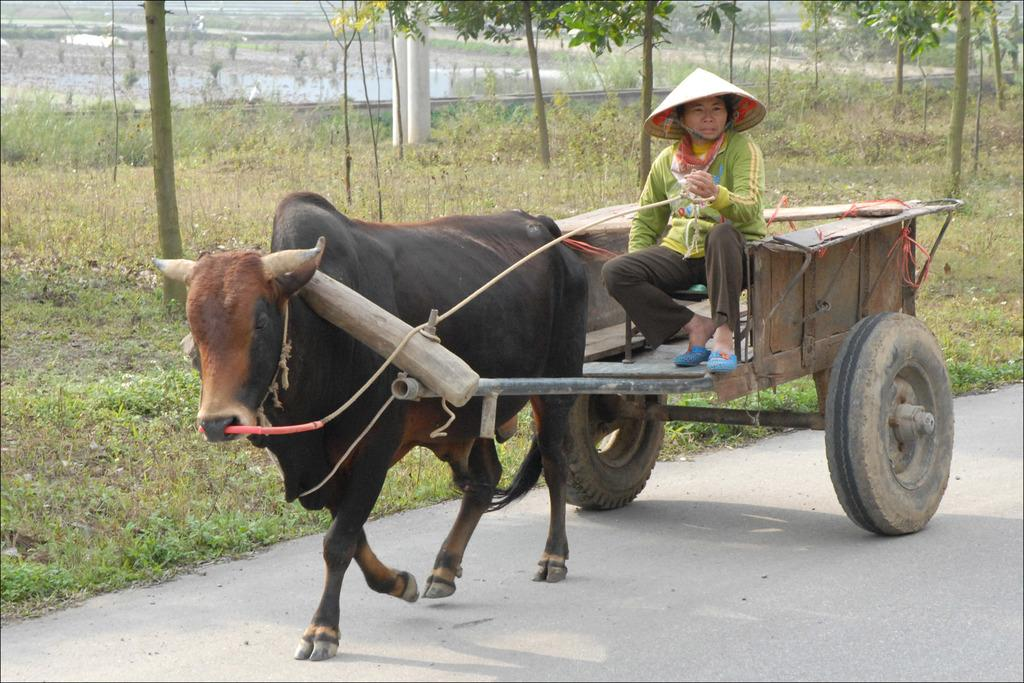What is the main subject in the foreground of the image? There is a bull cart in the foreground of the image. Who is present on the bull cart? A man is sitting on the bull cart. What is the bull cart doing in the image? The bull cart is moving on a road. What can be seen in the background of the image? There are trees, poles, and farming fields visible in the background of the image. What is the profit margin of the trip shown in the image? There is no information about profit or a trip in the image; it simply shows a man on a moving bull cart. 